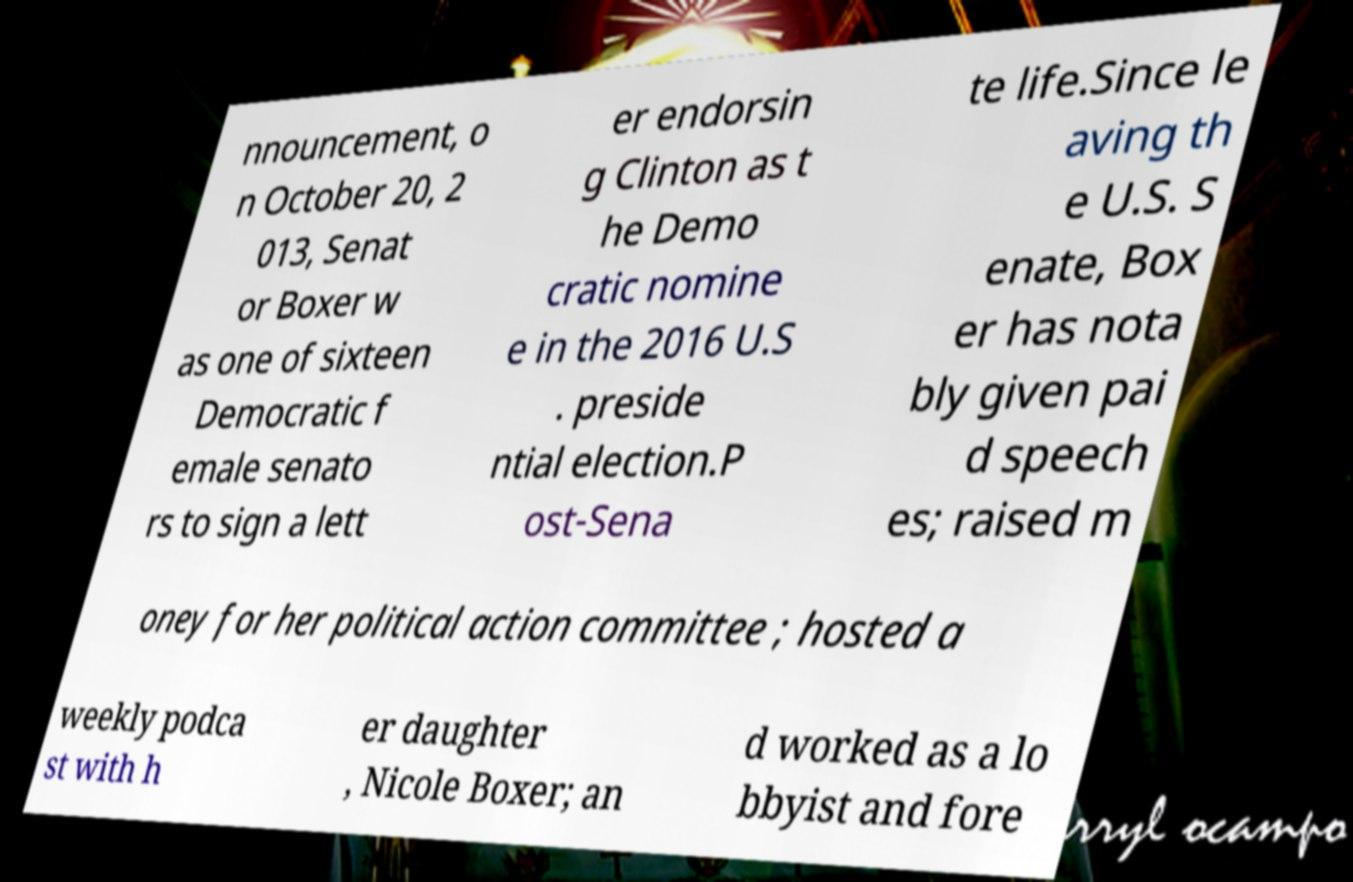Can you accurately transcribe the text from the provided image for me? nnouncement, o n October 20, 2 013, Senat or Boxer w as one of sixteen Democratic f emale senato rs to sign a lett er endorsin g Clinton as t he Demo cratic nomine e in the 2016 U.S . preside ntial election.P ost-Sena te life.Since le aving th e U.S. S enate, Box er has nota bly given pai d speech es; raised m oney for her political action committee ; hosted a weekly podca st with h er daughter , Nicole Boxer; an d worked as a lo bbyist and fore 